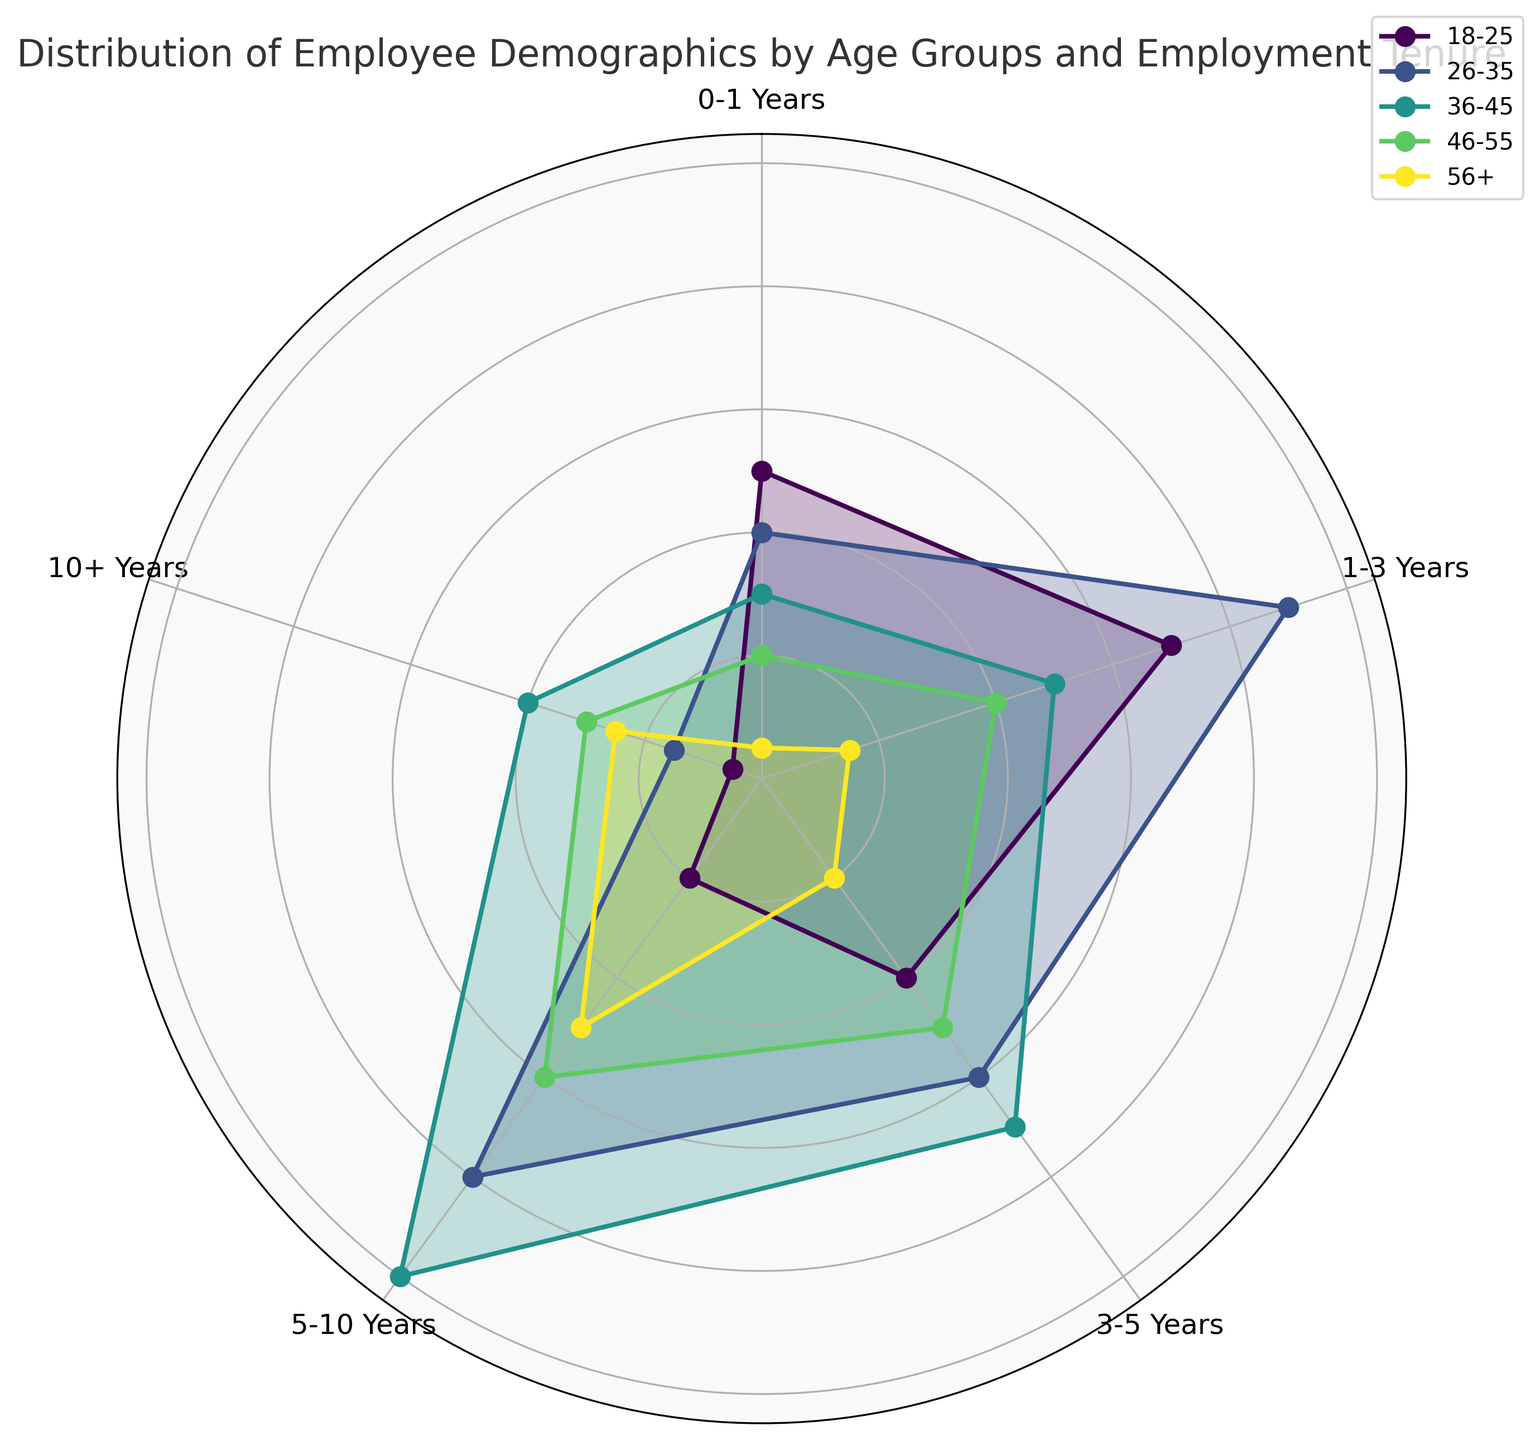What is the age group with the highest count for employees with 3-5 years of tenure? First, locate the section of the chart corresponding to the 3-5 years category, then compare the heights of each segment for different age groups. The tallest segment within this category represents the age group with the highest count. For the 3-5 years category, the 36-45 age group has the highest count.
Answer: 36-45 Which age group has the smallest number of employees with 0-1 years of tenure? Locate the segments on the chart for the 0-1 years category and identify the shortest segment, which represents the smallest count. The 56+ age group has the shortest segment in this category.
Answer: 56+ How do the counts of employees with 5-10 years of tenure compare between the 26-35 and 36-45 age groups? Find the segments for the 5-10 years category corresponding to the 26-35 and 36-45 age groups. Compare the heights of these segments. The 36-45 age group has a taller segment compared to the 26-35 age group, indicating a higher count.
Answer: 36-45 > 26-35 What is the combined count of employees aged 26-35 with tenure between 1 and 5 years? Look at the chart and find the segments for the 26-35 age group under the 1-3 years and 3-5 years categories. Add the heights of these segments together. The counts are 90 (1-3 years) and 60 (3-5 years). Summing these gives 150 employees.
Answer: 150 Which employment tenure category shows the highest count for employees aged 46-55? Identify the segments for the 46-55 age group across all tenure categories and compare their heights. The segment under the 5-10 years category is the tallest, indicating it has the highest count.
Answer: 5-10 years What is the visual difference between the 18-25 and 56+ age groups for the 5-10 years tenure? Look at the segments corresponding to the 5-10 years category for both age groups. Visually compare the lengths of these segments. The segment for the 56+ age group is taller compared to the 18-25 age group, indicating a higher count for the 56+ age group in this tenure.
Answer: 56+ group segment is taller How does the distribution of employees with 10+ years of tenure differ between the youngest (18-25) and the oldest (56+) age groups? Examine the segments for the 10+ years tenure for both the 18-25 and 56+ age groups. Compare their heights to see the differences. The 56+ age group has a taller segment indicating a higher number of employees with 10+ years tenure compared to the 18-25 age group.
Answer: 56+ > 18-25 Is there any age group where the number of employees with 1-3 years of tenure is higher than those with 0-1 years of tenure? Compare the segment heights for 1-3 years and 0-1 years categories within each age group. For the 26-35 and 18-25 age groups, the segment for 1-3 years is taller than for 0-1 years.
Answer: Yes, 26-35 and 18-25 What's the average count of employees aged 36-45 across all tenure categories? Sum the segment heights for the 36-45 age group across all tenure categories, then divide by the number of categories (5). The counts are 30, 50, 70, 100, and 40. The sum is 290, and the average is 290/5.
Answer: 58 